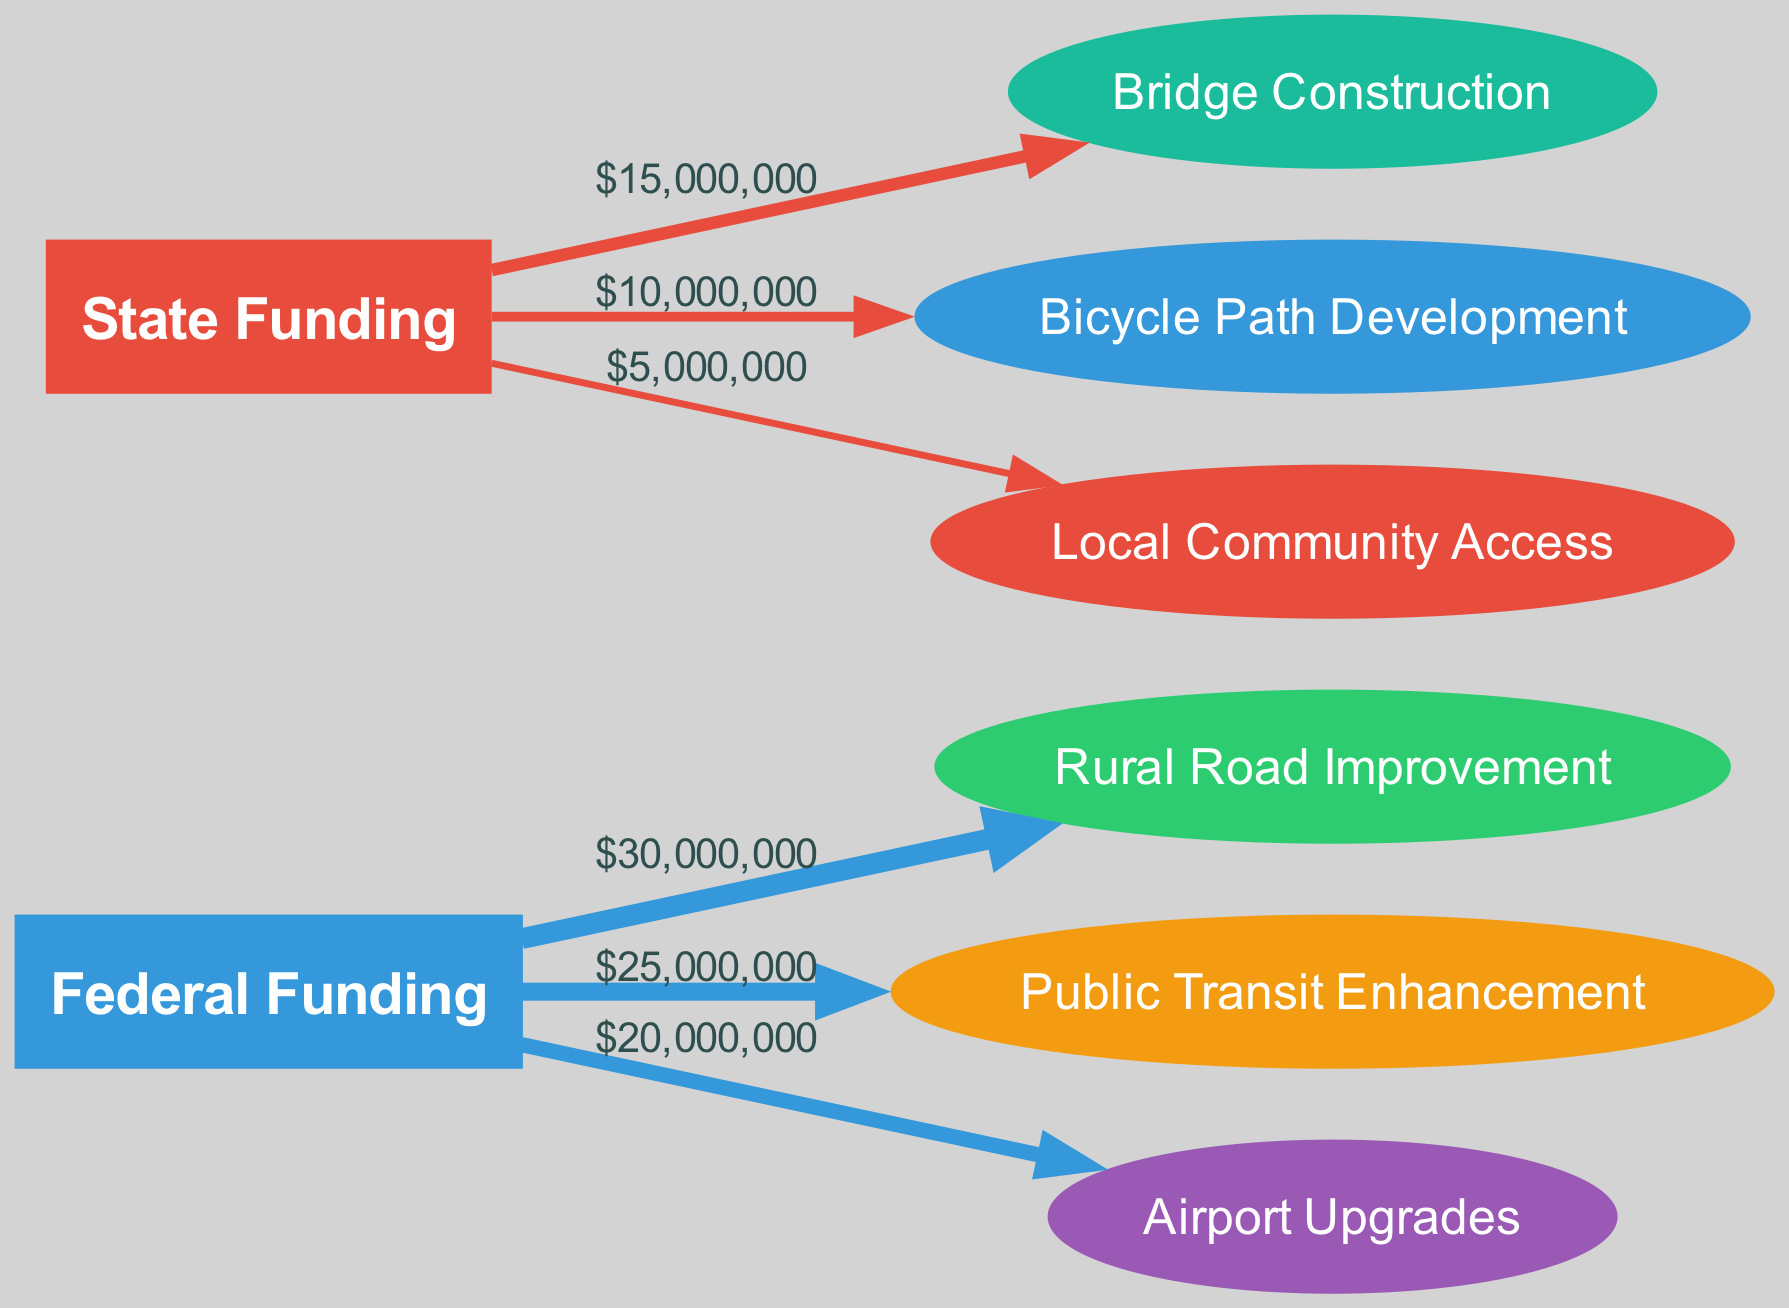What is the total federal funding allocated to Rural Road Improvement? The diagram shows a direct link from "Federal Funding" to "Rural Road Improvement" with a value of 30,000,000. Therefore, the total federal funding allocated is simply the value of that link.
Answer: 30,000,000 How much state funding is designated for Local Community Access? Looking at the diagram, there is a directed link from "State Funding" to "Local Community Access" with a value of 5,000,000. Thus, the amount of state funding for this project is clearly indicated by the link.
Answer: 5,000,000 Which project receives the least total funding? The diagram displays all projects and their respective funding amounts. The smallest value is 5,000,000, which corresponds to "Local Community Access." By comparing all the link values, it is evident this project receives the least funding.
Answer: Local Community Access What percentage of the total federal funding is allocated to Public Transit Enhancement? The total federal funding allocated amounts to 30,000,000 for Rural Road Improvement, 25,000,000 for Public Transit Enhancement, and 20,000,000 for Airport Upgrades, summing up to 75,000,000. Public Transit Enhancement's allocation is 25,000,000. To find the percentage, divide 25,000,000 by 75,000,000 and multiply by 100, resulting in approximately 33.33%.
Answer: 33.33% How do federal and state allocations compare in total funding for bridge projects? There is no direct federal funding allocated for "Bridge Construction," as it only receives 15,000,000 from state funding. Therefore, in terms of total funding for this project, the comparison shows that only state funding exists.
Answer: State Funding Only Which project has the largest allocation of funds? Analyzing the diagram, "Rural Road Improvement" has the highest value associated with it, at 30,000,000, indicating it receives the largest funding allocation compared to the other projects.
Answer: Rural Road Improvement What is the total funding from state sources across all projects? Summing the state funding values for projects shows: 15,000,000 (Bridge Construction) + 10,000,000 (Bicycle Path Development) + 5,000,000 (Local Community Access) equals 30,000,000. This provides a clear total for all state-based project funding.
Answer: 30,000,000 How many projects receive federal funding? By counting the links stemming from "Federal Funding," it is evident that three projects—Rural Road Improvement, Public Transit Enhancement, and Airport Upgrades—receive allocations. This can be directly observed in the diagram.
Answer: 3 What is the combined total funding from both federal and state sources? The federal funding totals 75,000,000 from three projects, and the state funding totals 30,000,000 from three projects. Adding both totals together (75,000,000 + 30,000,000) results in a combined total of 105,000,000, showcasing the overall investment.
Answer: 105,000,000 